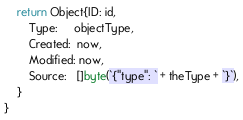Convert code to text. <code><loc_0><loc_0><loc_500><loc_500><_Go_>	return Object{ID: id,
		Type:     objectType,
		Created:  now,
		Modified: now,
		Source:   []byte(`{"type": ` + theType + `}`),
	}
}
</code> 